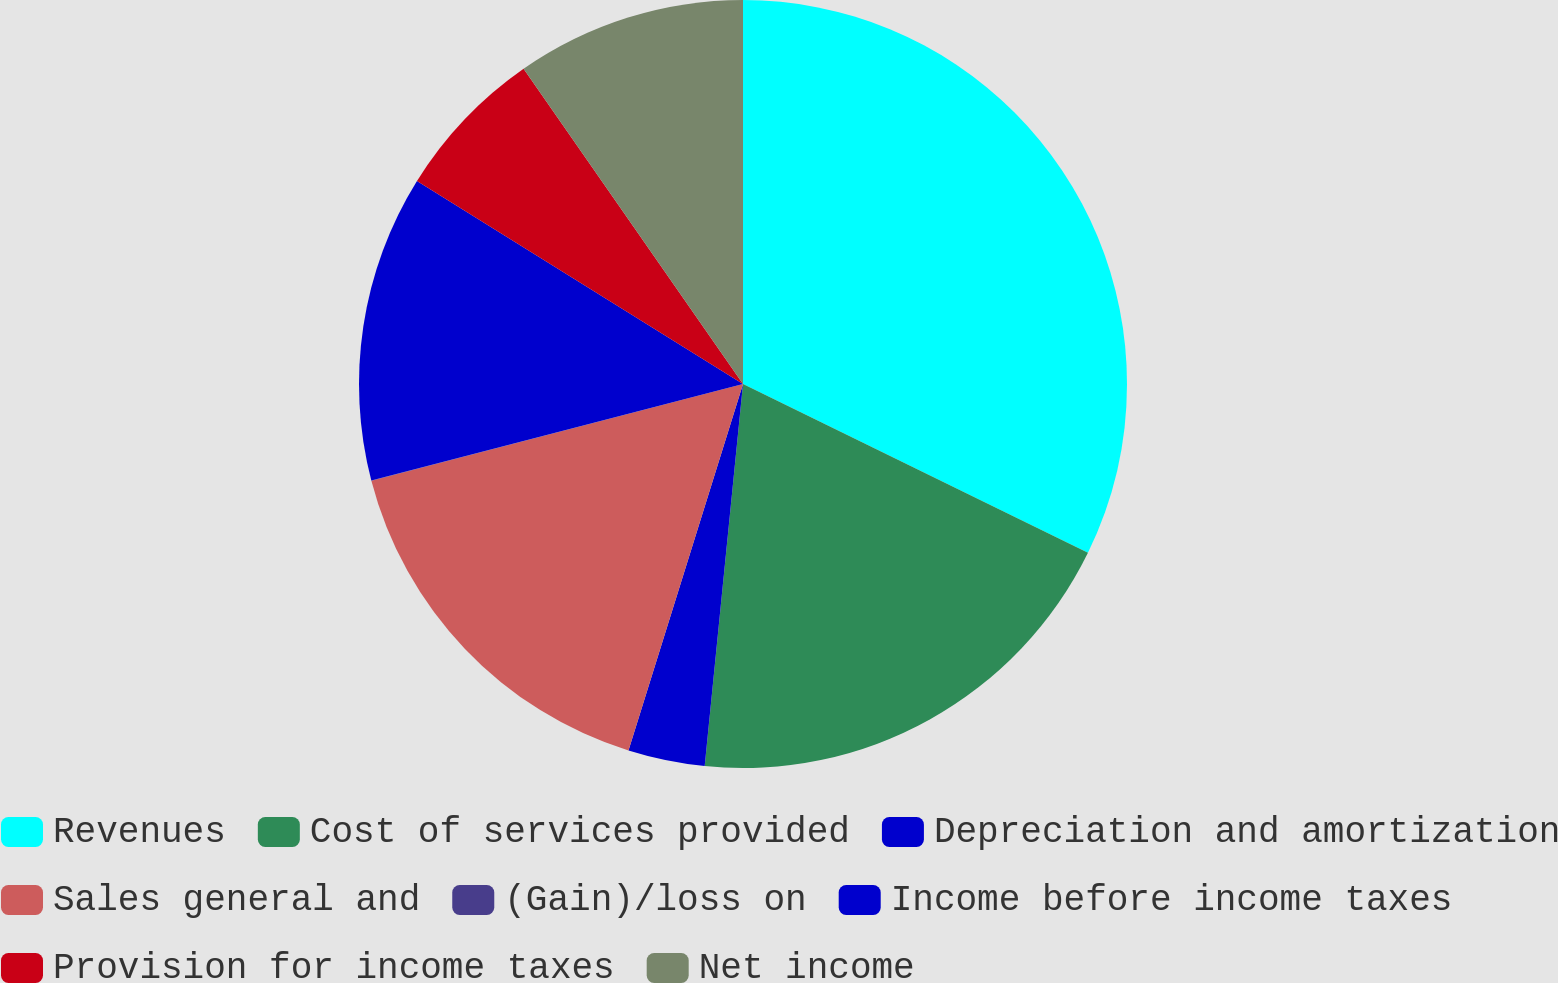Convert chart to OTSL. <chart><loc_0><loc_0><loc_500><loc_500><pie_chart><fcel>Revenues<fcel>Cost of services provided<fcel>Depreciation and amortization<fcel>Sales general and<fcel>(Gain)/loss on<fcel>Income before income taxes<fcel>Provision for income taxes<fcel>Net income<nl><fcel>32.24%<fcel>19.35%<fcel>3.23%<fcel>16.13%<fcel>0.01%<fcel>12.9%<fcel>6.46%<fcel>9.68%<nl></chart> 